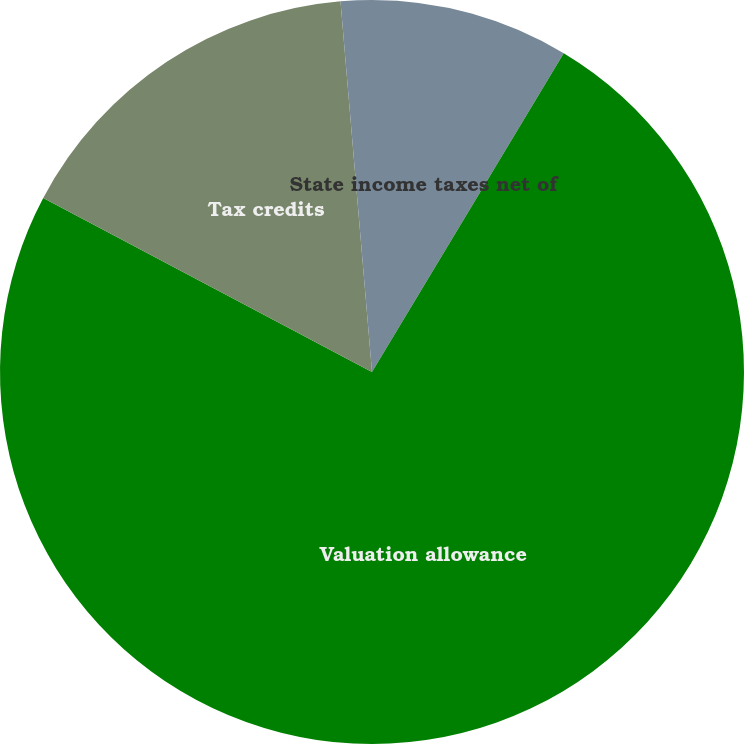Convert chart to OTSL. <chart><loc_0><loc_0><loc_500><loc_500><pie_chart><fcel>State income taxes net of<fcel>Valuation allowance<fcel>Tax credits<fcel>Other<nl><fcel>8.62%<fcel>74.13%<fcel>15.9%<fcel>1.35%<nl></chart> 